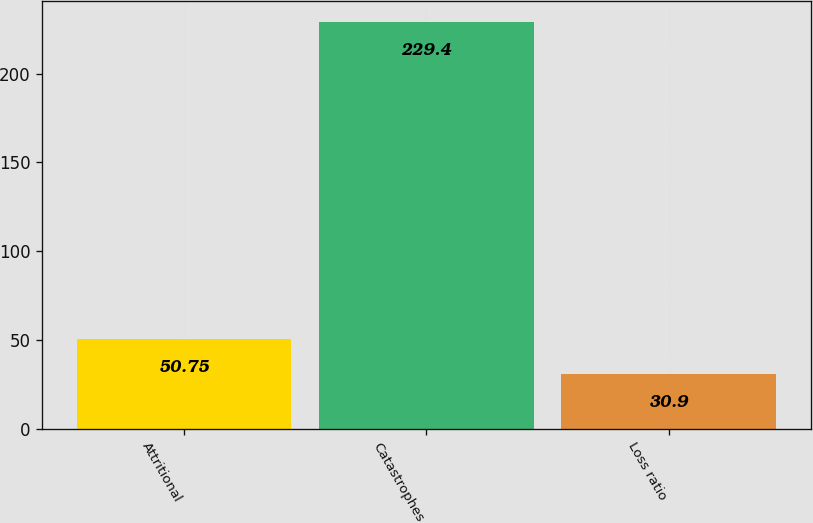<chart> <loc_0><loc_0><loc_500><loc_500><bar_chart><fcel>Attritional<fcel>Catastrophes<fcel>Loss ratio<nl><fcel>50.75<fcel>229.4<fcel>30.9<nl></chart> 